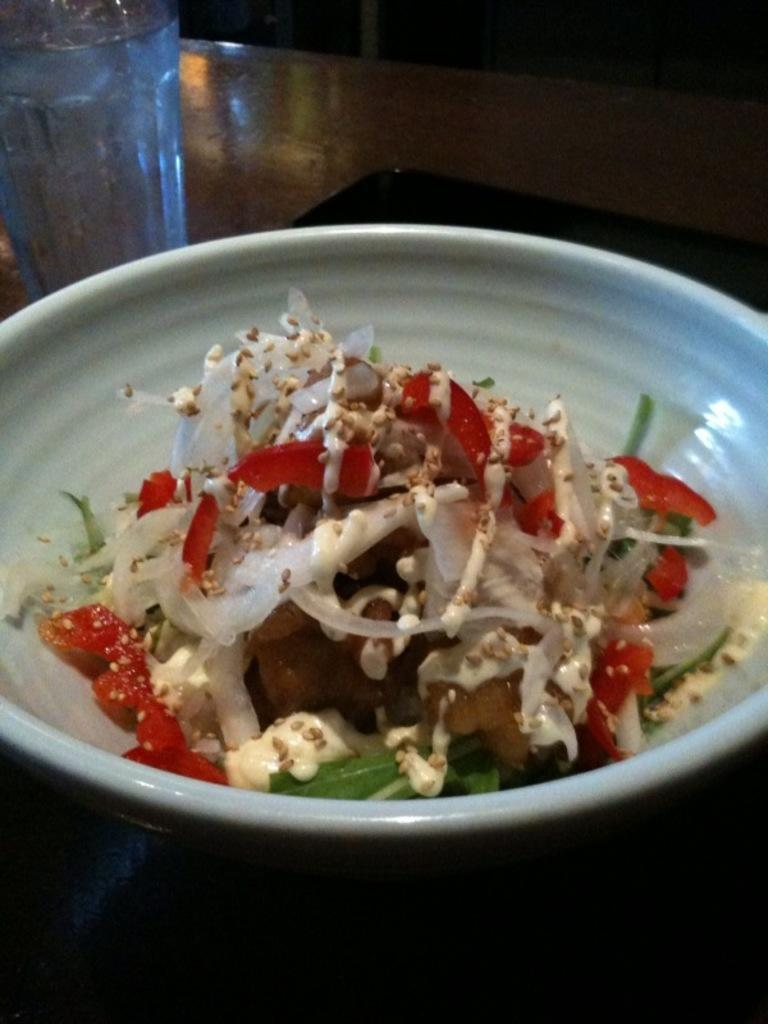What type of food is in the bowl in the image? The facts do not specify the type of food in the bowl. What beverage is in the glass in the image? The glass contains water, as mentioned in the facts. Where are the bowl and glass of water located in the image? Both the bowl and the glass of water are arranged on a table, as stated in the facts. What type of property is being insured in the image? There is no mention of property or insurance in the image, as the facts only describe a bowl of food and a glass of water on a table. 